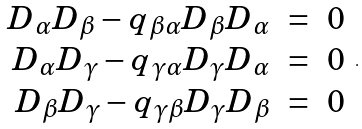<formula> <loc_0><loc_0><loc_500><loc_500>\begin{array} { r c l } D _ { \alpha } D _ { \beta } - q _ { \beta \alpha } D _ { \beta } D _ { \alpha } & = & 0 \\ D _ { \alpha } D _ { \gamma } - q _ { \gamma \alpha } D _ { \gamma } D _ { \alpha } & = & 0 \\ D _ { \beta } D _ { \gamma } - q _ { \gamma \beta } D _ { \gamma } D _ { \beta } & = & 0 \end{array} \, .</formula> 